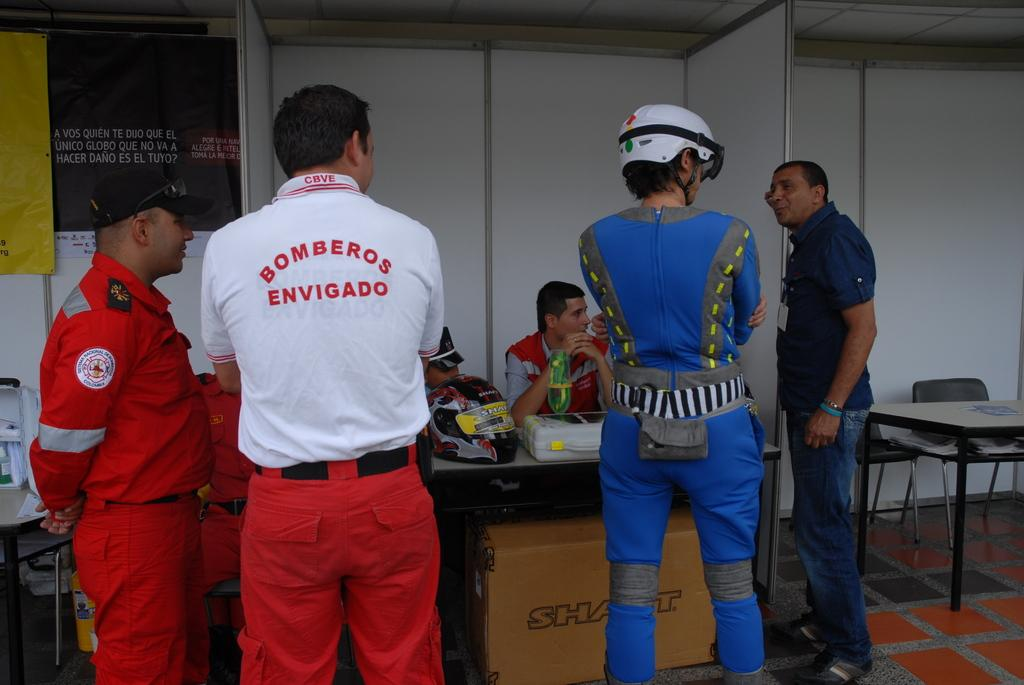<image>
Offer a succinct explanation of the picture presented. a person with the name Bomberos Enviqado on the back 